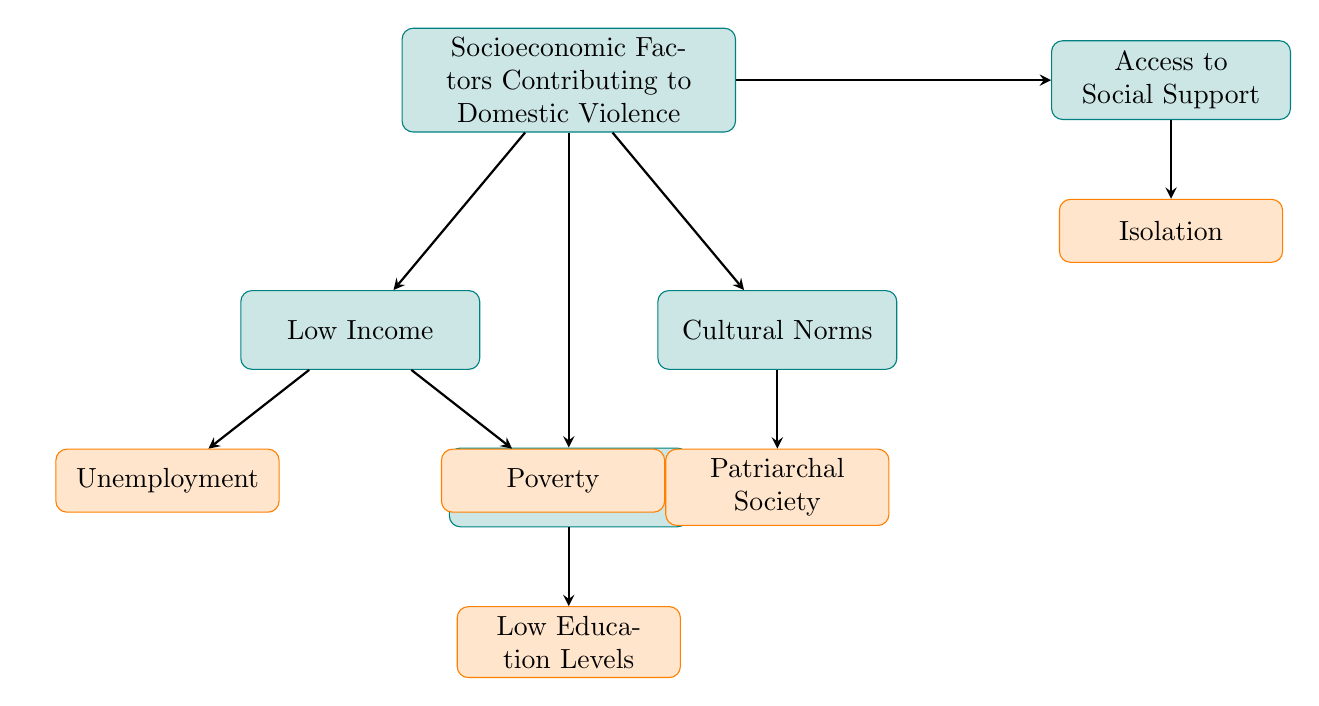What are the main socioeconomic factors contributing to domestic violence? The diagram identifies four main factors: Low Income, Education, Cultural Norms, and Access to Social Support. These are the primary categories displayed in the initial node of the flow chart.
Answer: Low Income, Education, Cultural Norms, Access to Social Support How many subfactors are listed under Low Income? The flow chart shows two subfactors under Low Income: Unemployment and Poverty. Counting these gives the total number of subfactors in that category.
Answer: 2 What does Poverty lead to according to the diagram? In the diagram, Poverty leads to Housing Instability, which is indicated as a consequence directly linked to that subfactor.
Answer: Housing Instability Which socioeconomic factor has a subfactor related to Limited Employment Opportunities? The Education category includes a subfactor titled Low Education Levels, which directly relates to Limited Employment Opportunities as a subsequent outcome.
Answer: Education If someone experiences Isolation in the context of social support, what is one consequence they face according to the chart? The flow chart outlines that Isolation, as a subfactor under Access to Social Support, results in Limited Social Networks, which is identified as a consequence tied to that aspect.
Answer: Limited Social Networks How do Cultural Norms impact family resource control? The diagram explains that the Patriarchal Society in Cultural Norms leads to Male Dominance, which translates to Control Over Family Resources, illustrating the connection between cultural beliefs and resource management.
Answer: Control Over Family Resources What is a consequence of Low Education Levels mentioned in the chart? The flow chart indicates that one of the consequences of Low Education Levels is Increased Financial Dependence, showcasing the direct link between education and economic outcomes.
Answer: Increased Financial Dependence What type of societal structure is indicated under Cultural Norms? The diagram specifies that a Patriarchal Society is the societal structure indicated under the Cultural Norms category, suggesting a gendered hierarchy.
Answer: Patriarchal Society What issue arises from Lack of Institutional Support in the context of social support? The flow chart links Lack of Institutional Support directly to Inadequate Access to Shelters and Counseling, showing the problem that emerges from insufficient institutional resources.
Answer: Inadequate Access to Shelters and Counseling 